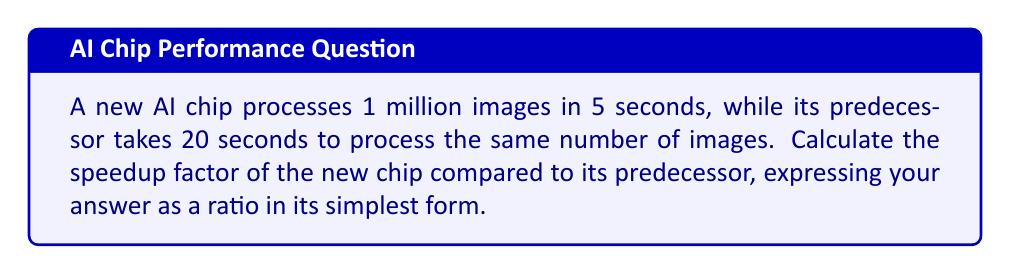Provide a solution to this math problem. To determine the speedup factor, we need to compare the processing times of the two chips:

1. Let's define our variables:
   $t_{new}$ = time taken by the new chip = 5 seconds
   $t_{old}$ = time taken by the old chip = 20 seconds

2. The speedup factor is calculated by dividing the old execution time by the new execution time:

   $$ \text{Speedup} = \frac{t_{old}}{t_{new}} $$

3. Substituting our values:

   $$ \text{Speedup} = \frac{20}{5} $$

4. Simplify the fraction:

   $$ \text{Speedup} = 4 $$

5. Express as a ratio:

   $$ \text{Speedup} = 4:1 $$

This means the new chip is 4 times faster than its predecessor.
Answer: 4:1 